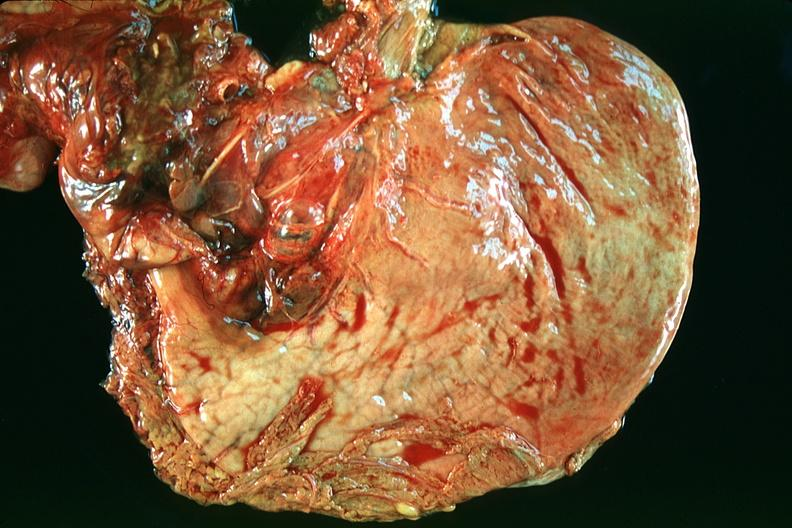what is present?
Answer the question using a single word or phrase. Gastrointestinal 